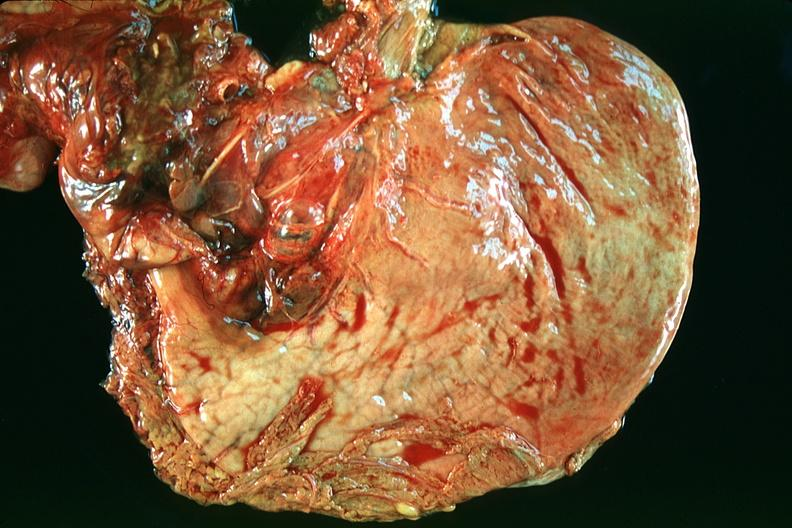what is present?
Answer the question using a single word or phrase. Gastrointestinal 